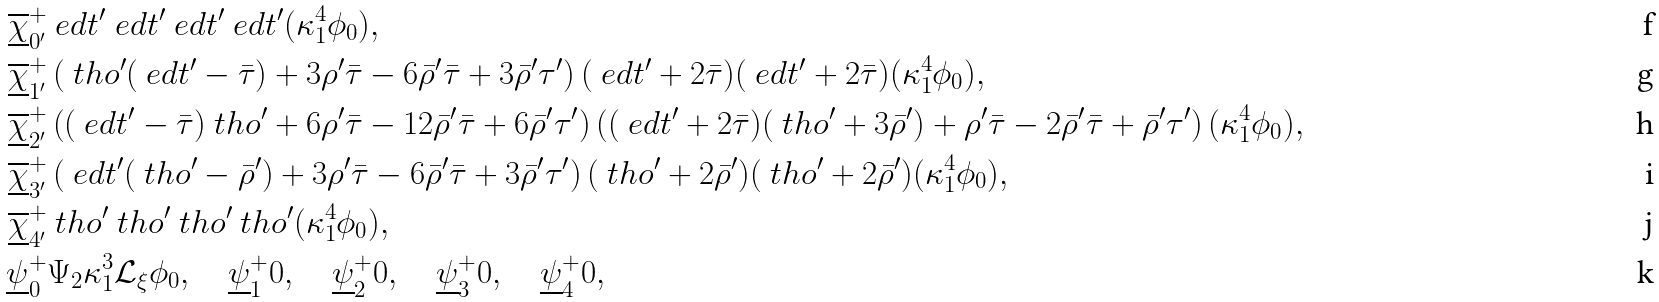Convert formula to latex. <formula><loc_0><loc_0><loc_500><loc_500>\overline { \underline { \chi } } ^ { + } _ { 0 ^ { \prime } } & \ e d t ^ { \prime } \ e d t ^ { \prime } \ e d t ^ { \prime } \ e d t ^ { \prime } ( \kappa _ { 1 } ^ { 4 } \phi _ { 0 } ) , \\ \overline { \underline { \chi } } ^ { + } _ { 1 ^ { \prime } } & \left ( \ t h o ^ { \prime } ( \ e d t ^ { \prime } - \bar { \tau } ) + 3 \rho ^ { \prime } \bar { \tau } - 6 \bar { \rho } ^ { \prime } \bar { \tau } + 3 \bar { \rho } ^ { \prime } \tau ^ { \prime } \right ) ( \ e d t ^ { \prime } + 2 \bar { \tau } ) ( \ e d t ^ { \prime } + 2 \bar { \tau } ) ( \kappa _ { 1 } ^ { 4 } \phi _ { 0 } ) , \\ \overline { \underline { \chi } } ^ { + } _ { 2 ^ { \prime } } & \left ( ( \ e d t ^ { \prime } - \bar { \tau } ) \ t h o ^ { \prime } + 6 \rho ^ { \prime } \bar { \tau } - 1 2 \bar { \rho } ^ { \prime } \bar { \tau } + 6 \bar { \rho } ^ { \prime } \tau ^ { \prime } \right ) \left ( ( \ e d t ^ { \prime } + 2 \bar { \tau } ) ( \ t h o ^ { \prime } + 3 \bar { \rho } ^ { \prime } ) + \rho ^ { \prime } \bar { \tau } - 2 \bar { \rho } ^ { \prime } \bar { \tau } + \bar { \rho } ^ { \prime } \tau ^ { \prime } \right ) ( \kappa _ { 1 } ^ { 4 } \phi _ { 0 } ) , \\ \overline { \underline { \chi } } ^ { + } _ { 3 ^ { \prime } } & \left ( \ e d t ^ { \prime } ( \ t h o ^ { \prime } - \bar { \rho } ^ { \prime } ) + 3 \rho ^ { \prime } \bar { \tau } - 6 \bar { \rho } ^ { \prime } \bar { \tau } + 3 \bar { \rho } ^ { \prime } \tau ^ { \prime } \right ) ( \ t h o ^ { \prime } + 2 \bar { \rho } ^ { \prime } ) ( \ t h o ^ { \prime } + 2 \bar { \rho } ^ { \prime } ) ( \kappa _ { 1 } ^ { 4 } \phi _ { 0 } ) , \\ \overline { \underline { \chi } } ^ { + } _ { 4 ^ { \prime } } & \ t h o ^ { \prime } \ t h o ^ { \prime } \ t h o ^ { \prime } \ t h o ^ { \prime } ( \kappa _ { 1 } ^ { 4 } \phi _ { 0 } ) , \\ \underline { \psi } ^ { + } _ { 0 } & \Psi _ { 2 } \kappa _ { 1 } ^ { 3 } \mathcal { L } _ { \xi } \phi _ { 0 } , \quad \underline { \psi } ^ { + } _ { 1 } 0 , \quad \underline { \psi } ^ { + } _ { 2 } 0 , \quad \underline { \psi } ^ { + } _ { 3 } 0 , \quad \underline { \psi } ^ { + } _ { 4 } 0 ,</formula> 